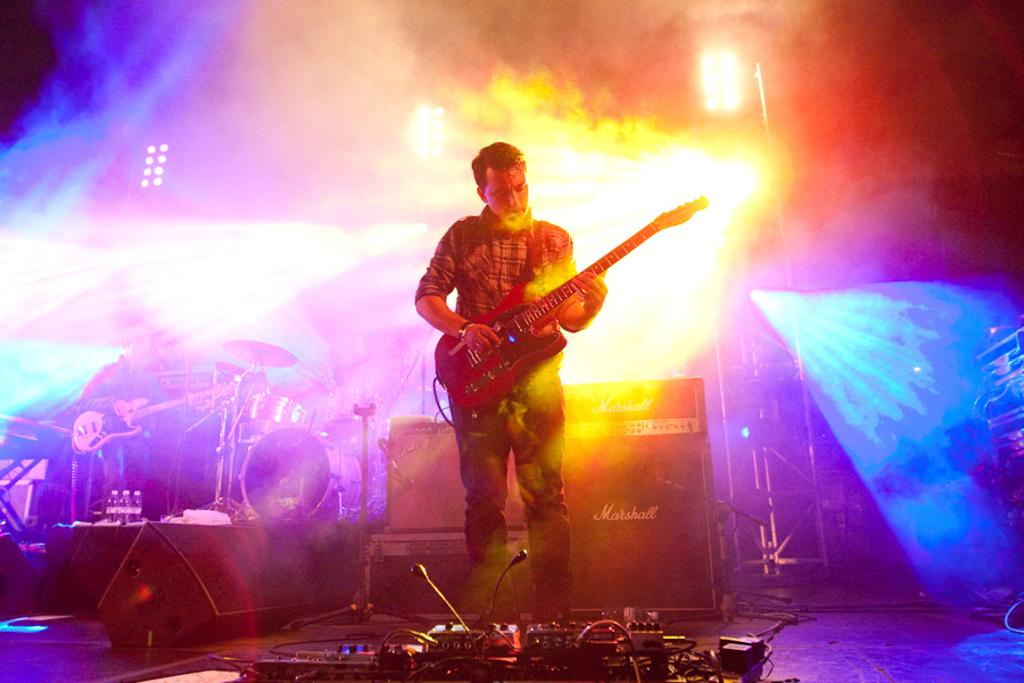What is the man in the foreground of the image doing? The man in the foreground is standing and playing a guitar in the image. What can be seen in the background of the image? In the background, there are cables, speakers, and another man standing. What is the second man in the background doing? The second man in the background is playing a guitar or drums. Can you describe any lighting features in the image? Yes, there are focus lights in the image. How many tomatoes are on the man's pocket in the image? There are no tomatoes or pockets mentioned in the image; the man is playing a guitar. 